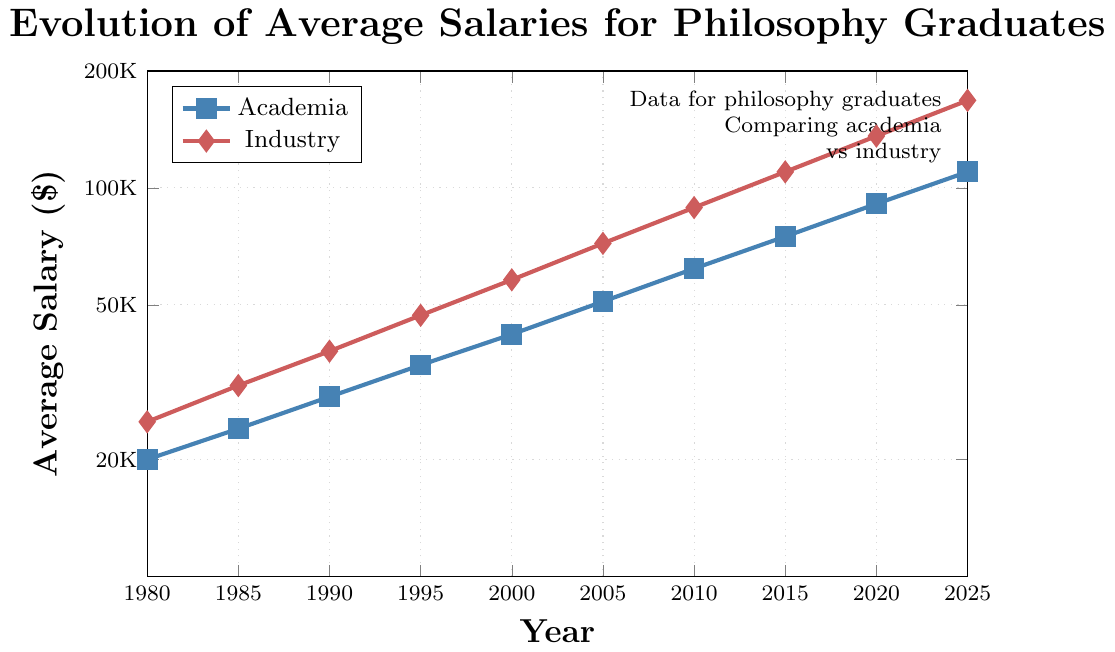What is the average salary in academia in 1990? Locate the year 1990 on the x-axis and find the corresponding salary value for the academia line (marked in blue). The salary is $29,000.
Answer: $29,000 What was the salary difference between academia and industry in 2000? Locate the year 2000 on the x-axis and find the corresponding values for both academia ($42,000) and industry ($58,000) lines. Subtract the academia salary from the industry salary ($58,000 - $42,000 = $16,000).
Answer: $16,000 By approximately how much did the average salary in industry increase from 1980 to 2025? Locate the years 1980 and 2025 on the x-axis and find the corresponding values for the industry line (marked in red). In 1980, the salary was $25,000 and in 2025, it is $168,000. Subtract the 1980 value from the 2025 value ($168,000 - $25,000 = $143,000).
Answer: $143,000 Which sector shows a steeper increase in salaries over time? Compare the slopes of the two lines: academia (blue) and industry (red). The industry line shows a steeper slope, indicating a faster rate of salary increase.
Answer: Industry What is the ratio of industry to academia salaries for the year 2020? Locate the year 2020 on the x-axis and find the corresponding values for both academia ($91,000) and industry ($136,000). Divide the industry salary by the academia salary ($136,000 / $91,000 ≈ 1.49).
Answer: 1.49 In which year did the average salary in academia exceed $50,000? Find the first year on the x-axis where the blue academia line crosses the $50,000 mark on the y-axis. The year is 2005.
Answer: 2005 How has the gap between academia and industry salaries evolved from 1980 to 2025? Compare the salary differences over the years: In 1980, the gap is $5,000 ($25,000 - $20,000). In 2025, the gap is $58,000 ($168,000 - $110,000). The gap has widened over time.
Answer: Widened What is the percentage increase in academia salaries from 2000 to 2015? Locate the years 2000 and 2015 on the x-axis and find the corresponding academia salaries ($42,000 and $75,000). Use the formula: ((new value - old value) / old value) * 100 = ((75,000 - 42,000) / 42,000) * 100 ≈ 78.6%.
Answer: 78.6% What is the largest observed salary in the industry sector in the period shown? Identify the highest point for the red industry line, which is in 2025 with a value of $168,000.
Answer: $168,000 In what year did industry salaries reach approximately 75% more than academia salaries? Start by calculating 75% more for various years (e.g., in 1990, 75% of $29,000 = $21,750 and adding it to $29,000 = $50,750). Match this with industry salaries, which reaches around 1995 where the industry salary is $47,000.
Answer: 1995 